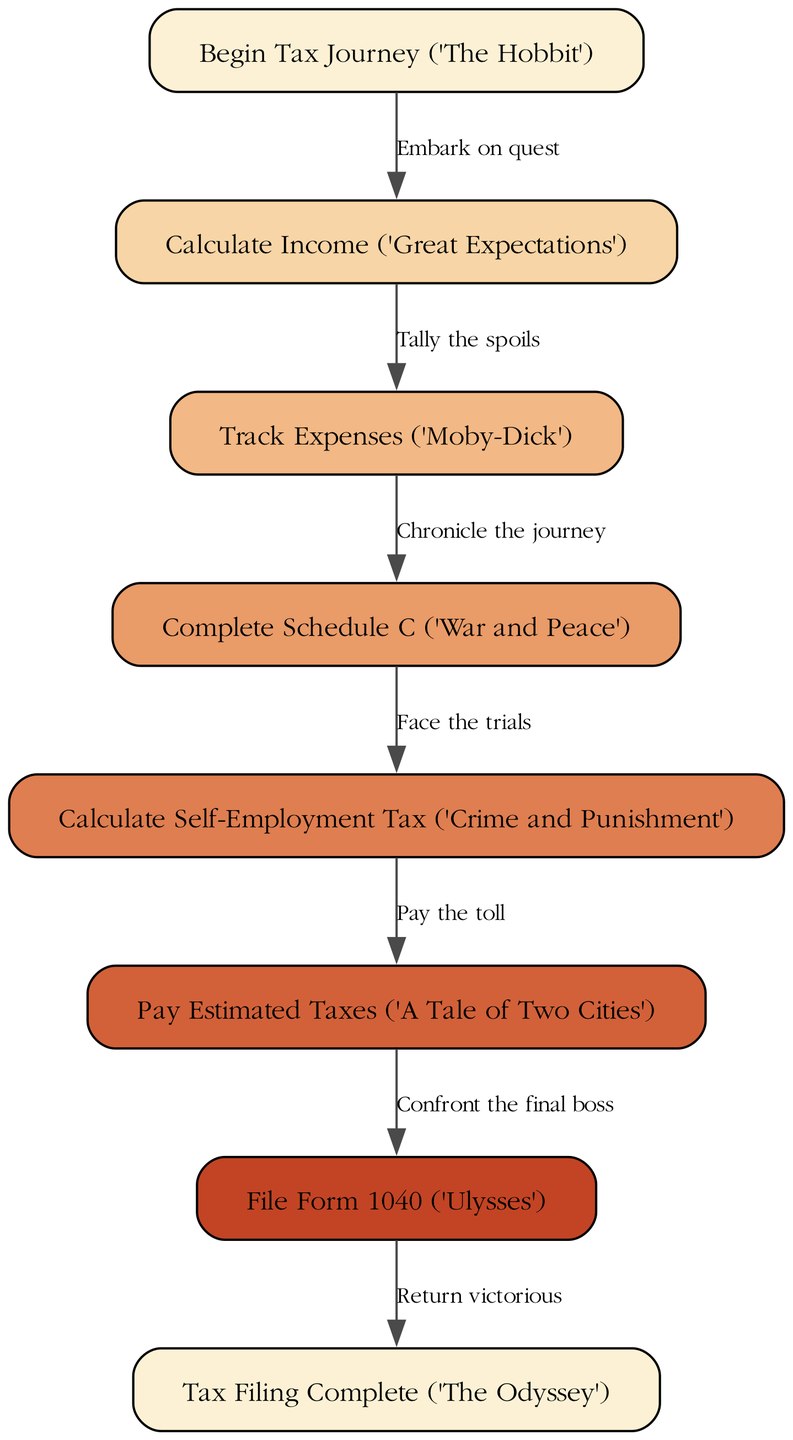What is the first step in the tax filing process? The first step indicated in the diagram is labeled "Begin Tax Journey" and is associated with "The Hobbit." This represents the starting point of the flowchart.
Answer: Begin Tax Journey ('The Hobbit') How many nodes are present in the diagram? The diagram contains a total of eight nodes, ranging from the start point to the completion of the tax filing process. They encompass all the essential steps listed.
Answer: Eight What literary work is referenced when calculating self-employment tax? The node for calculating self-employment tax is associated with the literary work "Crime and Punishment," indicating its importance in this step of the process.
Answer: Crime and Punishment What is the relationship between tracking expenses and completing Schedule C? The flow indicates that after tracking expenses, the next step is completing Schedule C, implying a direct progression from one task to another in the tax filing process.
Answer: Chronicle the journey What is the final step before tax filing is complete? The last action before the tax filing is complete involves filing Form 1040, which is marked in the diagram as the penultimate step.
Answer: File Form 1040 ('Ulysses') What is the last node called in the diagram? The last node, which signifies the end of the tax filing process, is labeled "Tax Filing Complete" and is associated with "The Odyssey." This marks the conclusion of the flowchart.
Answer: Tax Filing Complete ('The Odyssey') How do you transition from paying estimated taxes to filing Form 1040? The transition occurs by moving from the node for paying estimated taxes directly to the node for filing Form 1040, showing a linear progression leading up to this final filing.
Answer: Confront the final boss What step involves calculating income? The step that involves calculating income is labeled "Calculate Income" and references "Great Expectations." This defines the financial basis for the subsequent steps.
Answer: Calculate Income ('Great Expectations') 